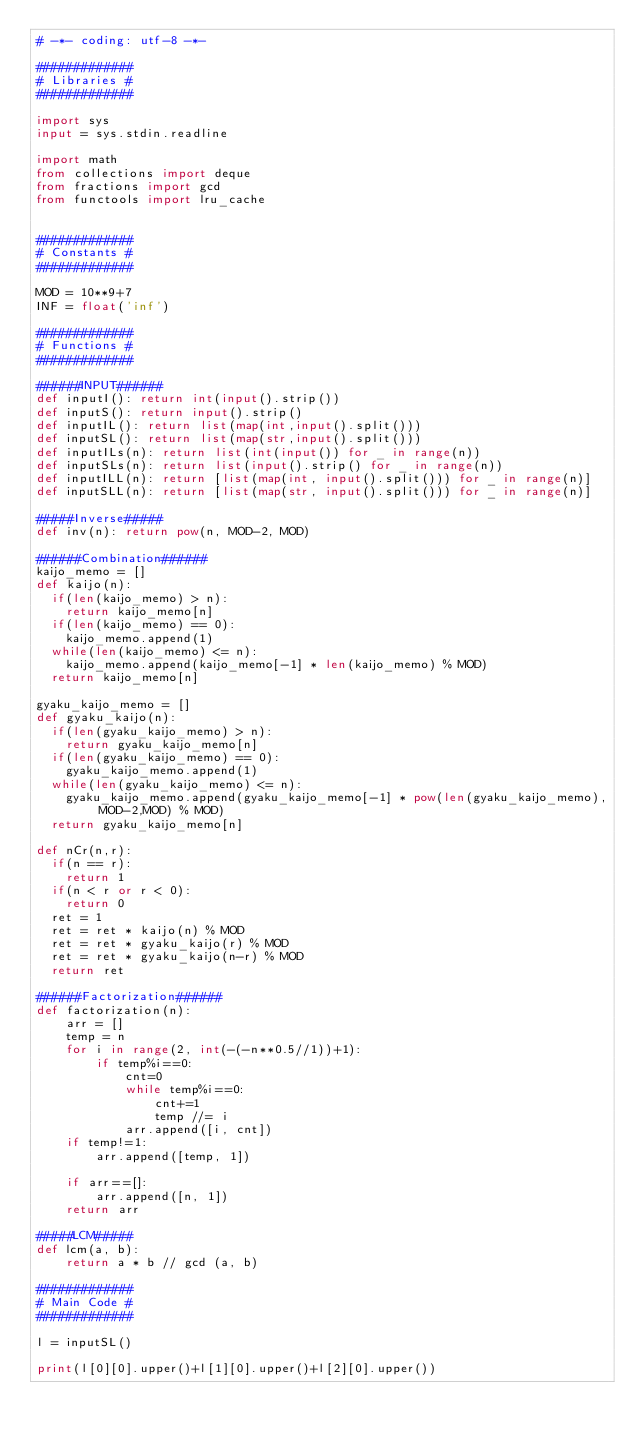Convert code to text. <code><loc_0><loc_0><loc_500><loc_500><_Python_># -*- coding: utf-8 -*-

#############
# Libraries #
#############

import sys
input = sys.stdin.readline

import math
from collections import deque
from fractions import gcd
from functools import lru_cache


#############
# Constants #
#############

MOD = 10**9+7
INF = float('inf')

#############
# Functions #
#############

######INPUT######
def inputI(): return int(input().strip())
def inputS(): return input().strip()
def inputIL(): return list(map(int,input().split()))
def inputSL(): return list(map(str,input().split()))
def inputILs(n): return list(int(input()) for _ in range(n))
def inputSLs(n): return list(input().strip() for _ in range(n))
def inputILL(n): return [list(map(int, input().split())) for _ in range(n)]
def inputSLL(n): return [list(map(str, input().split())) for _ in range(n)]

#####Inverse#####
def inv(n): return pow(n, MOD-2, MOD)

######Combination######
kaijo_memo = []
def kaijo(n):
  if(len(kaijo_memo) > n):
    return kaijo_memo[n]
  if(len(kaijo_memo) == 0):
    kaijo_memo.append(1)
  while(len(kaijo_memo) <= n):
    kaijo_memo.append(kaijo_memo[-1] * len(kaijo_memo) % MOD)
  return kaijo_memo[n]

gyaku_kaijo_memo = []
def gyaku_kaijo(n):
  if(len(gyaku_kaijo_memo) > n):
    return gyaku_kaijo_memo[n]
  if(len(gyaku_kaijo_memo) == 0):
    gyaku_kaijo_memo.append(1)
  while(len(gyaku_kaijo_memo) <= n):
    gyaku_kaijo_memo.append(gyaku_kaijo_memo[-1] * pow(len(gyaku_kaijo_memo),MOD-2,MOD) % MOD)
  return gyaku_kaijo_memo[n]

def nCr(n,r):
  if(n == r):
    return 1
  if(n < r or r < 0):
    return 0
  ret = 1
  ret = ret * kaijo(n) % MOD
  ret = ret * gyaku_kaijo(r) % MOD
  ret = ret * gyaku_kaijo(n-r) % MOD
  return ret

######Factorization######
def factorization(n):
    arr = []
    temp = n
    for i in range(2, int(-(-n**0.5//1))+1):
        if temp%i==0:
            cnt=0
            while temp%i==0:
                cnt+=1
                temp //= i
            arr.append([i, cnt])
    if temp!=1:
        arr.append([temp, 1])

    if arr==[]:
        arr.append([n, 1])
    return arr

#####LCM#####
def lcm(a, b):
    return a * b // gcd (a, b)

#############
# Main Code #
#############

l = inputSL()

print(l[0][0].upper()+l[1][0].upper()+l[2][0].upper())</code> 